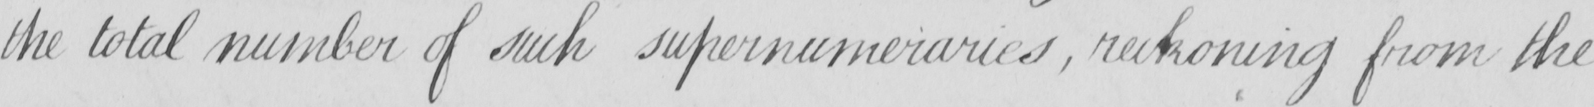Can you read and transcribe this handwriting? the total number of such supernumeraries , reckoning from the 